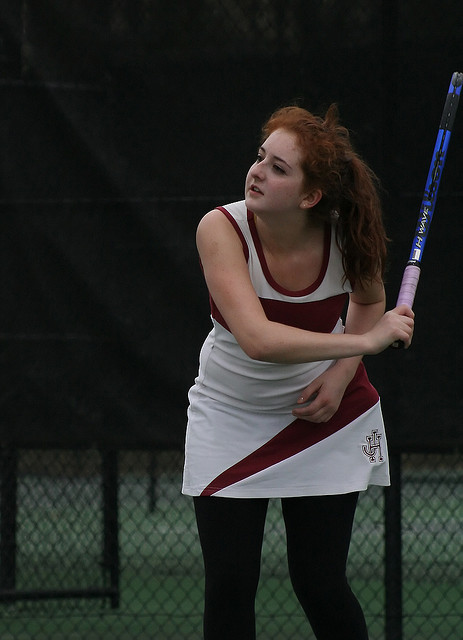Please transcribe the text in this image. HWAV WAVE H 